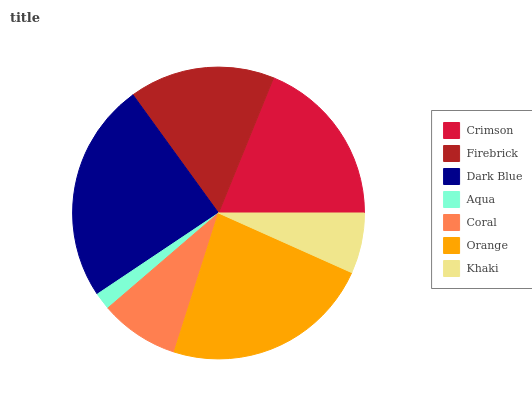Is Aqua the minimum?
Answer yes or no. Yes. Is Dark Blue the maximum?
Answer yes or no. Yes. Is Firebrick the minimum?
Answer yes or no. No. Is Firebrick the maximum?
Answer yes or no. No. Is Crimson greater than Firebrick?
Answer yes or no. Yes. Is Firebrick less than Crimson?
Answer yes or no. Yes. Is Firebrick greater than Crimson?
Answer yes or no. No. Is Crimson less than Firebrick?
Answer yes or no. No. Is Firebrick the high median?
Answer yes or no. Yes. Is Firebrick the low median?
Answer yes or no. Yes. Is Khaki the high median?
Answer yes or no. No. Is Crimson the low median?
Answer yes or no. No. 